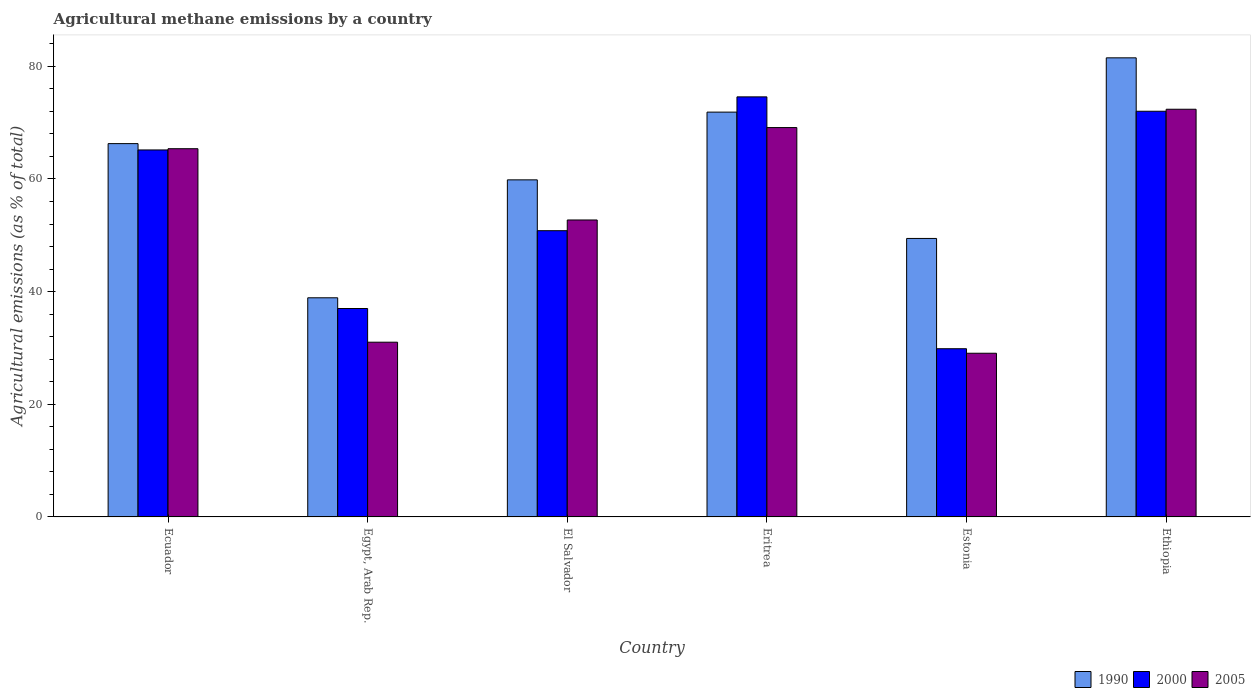How many groups of bars are there?
Provide a short and direct response. 6. How many bars are there on the 1st tick from the left?
Provide a short and direct response. 3. What is the label of the 4th group of bars from the left?
Provide a succinct answer. Eritrea. What is the amount of agricultural methane emitted in 2000 in Ethiopia?
Offer a very short reply. 72.02. Across all countries, what is the maximum amount of agricultural methane emitted in 1990?
Ensure brevity in your answer.  81.5. Across all countries, what is the minimum amount of agricultural methane emitted in 2005?
Keep it short and to the point. 29.06. In which country was the amount of agricultural methane emitted in 1990 maximum?
Keep it short and to the point. Ethiopia. In which country was the amount of agricultural methane emitted in 2005 minimum?
Ensure brevity in your answer.  Estonia. What is the total amount of agricultural methane emitted in 2005 in the graph?
Offer a very short reply. 319.67. What is the difference between the amount of agricultural methane emitted in 1990 in Ecuador and that in Ethiopia?
Your answer should be very brief. -15.23. What is the difference between the amount of agricultural methane emitted in 1990 in Estonia and the amount of agricultural methane emitted in 2005 in Egypt, Arab Rep.?
Provide a short and direct response. 18.42. What is the average amount of agricultural methane emitted in 2005 per country?
Your answer should be very brief. 53.28. What is the difference between the amount of agricultural methane emitted of/in 2005 and amount of agricultural methane emitted of/in 2000 in Eritrea?
Offer a terse response. -5.45. In how many countries, is the amount of agricultural methane emitted in 2000 greater than 40 %?
Provide a short and direct response. 4. What is the ratio of the amount of agricultural methane emitted in 2000 in Eritrea to that in Estonia?
Give a very brief answer. 2.5. Is the difference between the amount of agricultural methane emitted in 2005 in El Salvador and Ethiopia greater than the difference between the amount of agricultural methane emitted in 2000 in El Salvador and Ethiopia?
Your response must be concise. Yes. What is the difference between the highest and the second highest amount of agricultural methane emitted in 2000?
Give a very brief answer. 6.87. What is the difference between the highest and the lowest amount of agricultural methane emitted in 2005?
Offer a very short reply. 43.32. Is the sum of the amount of agricultural methane emitted in 1990 in Ecuador and Eritrea greater than the maximum amount of agricultural methane emitted in 2000 across all countries?
Offer a very short reply. Yes. What does the 1st bar from the left in Estonia represents?
Keep it short and to the point. 1990. What does the 2nd bar from the right in Ecuador represents?
Ensure brevity in your answer.  2000. Is it the case that in every country, the sum of the amount of agricultural methane emitted in 2000 and amount of agricultural methane emitted in 2005 is greater than the amount of agricultural methane emitted in 1990?
Your answer should be very brief. Yes. Are all the bars in the graph horizontal?
Ensure brevity in your answer.  No. How many countries are there in the graph?
Your response must be concise. 6. Does the graph contain any zero values?
Offer a very short reply. No. How are the legend labels stacked?
Your answer should be compact. Horizontal. What is the title of the graph?
Make the answer very short. Agricultural methane emissions by a country. What is the label or title of the Y-axis?
Keep it short and to the point. Agricultural emissions (as % of total). What is the Agricultural emissions (as % of total) in 1990 in Ecuador?
Offer a very short reply. 66.27. What is the Agricultural emissions (as % of total) of 2000 in Ecuador?
Offer a very short reply. 65.15. What is the Agricultural emissions (as % of total) of 2005 in Ecuador?
Keep it short and to the point. 65.37. What is the Agricultural emissions (as % of total) of 1990 in Egypt, Arab Rep.?
Provide a succinct answer. 38.9. What is the Agricultural emissions (as % of total) of 2000 in Egypt, Arab Rep.?
Your response must be concise. 37. What is the Agricultural emissions (as % of total) of 2005 in Egypt, Arab Rep.?
Make the answer very short. 31.02. What is the Agricultural emissions (as % of total) of 1990 in El Salvador?
Your answer should be very brief. 59.84. What is the Agricultural emissions (as % of total) of 2000 in El Salvador?
Make the answer very short. 50.82. What is the Agricultural emissions (as % of total) in 2005 in El Salvador?
Keep it short and to the point. 52.72. What is the Agricultural emissions (as % of total) of 1990 in Eritrea?
Offer a terse response. 71.87. What is the Agricultural emissions (as % of total) in 2000 in Eritrea?
Your answer should be compact. 74.57. What is the Agricultural emissions (as % of total) of 2005 in Eritrea?
Ensure brevity in your answer.  69.12. What is the Agricultural emissions (as % of total) in 1990 in Estonia?
Offer a terse response. 49.44. What is the Agricultural emissions (as % of total) of 2000 in Estonia?
Your response must be concise. 29.86. What is the Agricultural emissions (as % of total) in 2005 in Estonia?
Your response must be concise. 29.06. What is the Agricultural emissions (as % of total) in 1990 in Ethiopia?
Your answer should be very brief. 81.5. What is the Agricultural emissions (as % of total) in 2000 in Ethiopia?
Provide a succinct answer. 72.02. What is the Agricultural emissions (as % of total) of 2005 in Ethiopia?
Ensure brevity in your answer.  72.38. Across all countries, what is the maximum Agricultural emissions (as % of total) of 1990?
Ensure brevity in your answer.  81.5. Across all countries, what is the maximum Agricultural emissions (as % of total) of 2000?
Make the answer very short. 74.57. Across all countries, what is the maximum Agricultural emissions (as % of total) of 2005?
Make the answer very short. 72.38. Across all countries, what is the minimum Agricultural emissions (as % of total) in 1990?
Provide a succinct answer. 38.9. Across all countries, what is the minimum Agricultural emissions (as % of total) of 2000?
Provide a short and direct response. 29.86. Across all countries, what is the minimum Agricultural emissions (as % of total) of 2005?
Give a very brief answer. 29.06. What is the total Agricultural emissions (as % of total) in 1990 in the graph?
Your answer should be compact. 367.83. What is the total Agricultural emissions (as % of total) in 2000 in the graph?
Offer a very short reply. 329.43. What is the total Agricultural emissions (as % of total) of 2005 in the graph?
Make the answer very short. 319.67. What is the difference between the Agricultural emissions (as % of total) of 1990 in Ecuador and that in Egypt, Arab Rep.?
Give a very brief answer. 27.37. What is the difference between the Agricultural emissions (as % of total) in 2000 in Ecuador and that in Egypt, Arab Rep.?
Offer a terse response. 28.15. What is the difference between the Agricultural emissions (as % of total) in 2005 in Ecuador and that in Egypt, Arab Rep.?
Make the answer very short. 34.35. What is the difference between the Agricultural emissions (as % of total) in 1990 in Ecuador and that in El Salvador?
Give a very brief answer. 6.43. What is the difference between the Agricultural emissions (as % of total) of 2000 in Ecuador and that in El Salvador?
Provide a short and direct response. 14.33. What is the difference between the Agricultural emissions (as % of total) in 2005 in Ecuador and that in El Salvador?
Make the answer very short. 12.65. What is the difference between the Agricultural emissions (as % of total) in 1990 in Ecuador and that in Eritrea?
Give a very brief answer. -5.59. What is the difference between the Agricultural emissions (as % of total) in 2000 in Ecuador and that in Eritrea?
Provide a short and direct response. -9.42. What is the difference between the Agricultural emissions (as % of total) in 2005 in Ecuador and that in Eritrea?
Ensure brevity in your answer.  -3.75. What is the difference between the Agricultural emissions (as % of total) of 1990 in Ecuador and that in Estonia?
Your response must be concise. 16.84. What is the difference between the Agricultural emissions (as % of total) in 2000 in Ecuador and that in Estonia?
Your answer should be very brief. 35.29. What is the difference between the Agricultural emissions (as % of total) of 2005 in Ecuador and that in Estonia?
Provide a succinct answer. 36.31. What is the difference between the Agricultural emissions (as % of total) in 1990 in Ecuador and that in Ethiopia?
Provide a succinct answer. -15.23. What is the difference between the Agricultural emissions (as % of total) of 2000 in Ecuador and that in Ethiopia?
Offer a terse response. -6.87. What is the difference between the Agricultural emissions (as % of total) in 2005 in Ecuador and that in Ethiopia?
Your answer should be compact. -7. What is the difference between the Agricultural emissions (as % of total) in 1990 in Egypt, Arab Rep. and that in El Salvador?
Give a very brief answer. -20.94. What is the difference between the Agricultural emissions (as % of total) in 2000 in Egypt, Arab Rep. and that in El Salvador?
Keep it short and to the point. -13.82. What is the difference between the Agricultural emissions (as % of total) in 2005 in Egypt, Arab Rep. and that in El Salvador?
Offer a very short reply. -21.7. What is the difference between the Agricultural emissions (as % of total) in 1990 in Egypt, Arab Rep. and that in Eritrea?
Give a very brief answer. -32.96. What is the difference between the Agricultural emissions (as % of total) in 2000 in Egypt, Arab Rep. and that in Eritrea?
Ensure brevity in your answer.  -37.57. What is the difference between the Agricultural emissions (as % of total) of 2005 in Egypt, Arab Rep. and that in Eritrea?
Provide a succinct answer. -38.1. What is the difference between the Agricultural emissions (as % of total) in 1990 in Egypt, Arab Rep. and that in Estonia?
Keep it short and to the point. -10.53. What is the difference between the Agricultural emissions (as % of total) in 2000 in Egypt, Arab Rep. and that in Estonia?
Your response must be concise. 7.14. What is the difference between the Agricultural emissions (as % of total) in 2005 in Egypt, Arab Rep. and that in Estonia?
Offer a terse response. 1.96. What is the difference between the Agricultural emissions (as % of total) of 1990 in Egypt, Arab Rep. and that in Ethiopia?
Provide a succinct answer. -42.6. What is the difference between the Agricultural emissions (as % of total) in 2000 in Egypt, Arab Rep. and that in Ethiopia?
Your answer should be compact. -35.02. What is the difference between the Agricultural emissions (as % of total) in 2005 in Egypt, Arab Rep. and that in Ethiopia?
Offer a very short reply. -41.36. What is the difference between the Agricultural emissions (as % of total) of 1990 in El Salvador and that in Eritrea?
Your response must be concise. -12.03. What is the difference between the Agricultural emissions (as % of total) of 2000 in El Salvador and that in Eritrea?
Give a very brief answer. -23.76. What is the difference between the Agricultural emissions (as % of total) of 2005 in El Salvador and that in Eritrea?
Provide a succinct answer. -16.4. What is the difference between the Agricultural emissions (as % of total) of 1990 in El Salvador and that in Estonia?
Your answer should be very brief. 10.4. What is the difference between the Agricultural emissions (as % of total) of 2000 in El Salvador and that in Estonia?
Your answer should be compact. 20.96. What is the difference between the Agricultural emissions (as % of total) in 2005 in El Salvador and that in Estonia?
Your response must be concise. 23.66. What is the difference between the Agricultural emissions (as % of total) of 1990 in El Salvador and that in Ethiopia?
Keep it short and to the point. -21.66. What is the difference between the Agricultural emissions (as % of total) in 2000 in El Salvador and that in Ethiopia?
Offer a very short reply. -21.21. What is the difference between the Agricultural emissions (as % of total) of 2005 in El Salvador and that in Ethiopia?
Offer a terse response. -19.66. What is the difference between the Agricultural emissions (as % of total) in 1990 in Eritrea and that in Estonia?
Make the answer very short. 22.43. What is the difference between the Agricultural emissions (as % of total) of 2000 in Eritrea and that in Estonia?
Your answer should be very brief. 44.71. What is the difference between the Agricultural emissions (as % of total) of 2005 in Eritrea and that in Estonia?
Provide a succinct answer. 40.06. What is the difference between the Agricultural emissions (as % of total) in 1990 in Eritrea and that in Ethiopia?
Your response must be concise. -9.64. What is the difference between the Agricultural emissions (as % of total) of 2000 in Eritrea and that in Ethiopia?
Offer a very short reply. 2.55. What is the difference between the Agricultural emissions (as % of total) of 2005 in Eritrea and that in Ethiopia?
Offer a very short reply. -3.25. What is the difference between the Agricultural emissions (as % of total) in 1990 in Estonia and that in Ethiopia?
Ensure brevity in your answer.  -32.07. What is the difference between the Agricultural emissions (as % of total) in 2000 in Estonia and that in Ethiopia?
Offer a terse response. -42.16. What is the difference between the Agricultural emissions (as % of total) of 2005 in Estonia and that in Ethiopia?
Offer a terse response. -43.32. What is the difference between the Agricultural emissions (as % of total) of 1990 in Ecuador and the Agricultural emissions (as % of total) of 2000 in Egypt, Arab Rep.?
Give a very brief answer. 29.27. What is the difference between the Agricultural emissions (as % of total) in 1990 in Ecuador and the Agricultural emissions (as % of total) in 2005 in Egypt, Arab Rep.?
Provide a succinct answer. 35.25. What is the difference between the Agricultural emissions (as % of total) in 2000 in Ecuador and the Agricultural emissions (as % of total) in 2005 in Egypt, Arab Rep.?
Make the answer very short. 34.13. What is the difference between the Agricultural emissions (as % of total) of 1990 in Ecuador and the Agricultural emissions (as % of total) of 2000 in El Salvador?
Offer a terse response. 15.46. What is the difference between the Agricultural emissions (as % of total) in 1990 in Ecuador and the Agricultural emissions (as % of total) in 2005 in El Salvador?
Keep it short and to the point. 13.56. What is the difference between the Agricultural emissions (as % of total) in 2000 in Ecuador and the Agricultural emissions (as % of total) in 2005 in El Salvador?
Provide a short and direct response. 12.43. What is the difference between the Agricultural emissions (as % of total) of 1990 in Ecuador and the Agricultural emissions (as % of total) of 2000 in Eritrea?
Your answer should be very brief. -8.3. What is the difference between the Agricultural emissions (as % of total) of 1990 in Ecuador and the Agricultural emissions (as % of total) of 2005 in Eritrea?
Your answer should be compact. -2.85. What is the difference between the Agricultural emissions (as % of total) in 2000 in Ecuador and the Agricultural emissions (as % of total) in 2005 in Eritrea?
Provide a short and direct response. -3.97. What is the difference between the Agricultural emissions (as % of total) in 1990 in Ecuador and the Agricultural emissions (as % of total) in 2000 in Estonia?
Your answer should be very brief. 36.41. What is the difference between the Agricultural emissions (as % of total) in 1990 in Ecuador and the Agricultural emissions (as % of total) in 2005 in Estonia?
Your response must be concise. 37.21. What is the difference between the Agricultural emissions (as % of total) in 2000 in Ecuador and the Agricultural emissions (as % of total) in 2005 in Estonia?
Offer a terse response. 36.09. What is the difference between the Agricultural emissions (as % of total) of 1990 in Ecuador and the Agricultural emissions (as % of total) of 2000 in Ethiopia?
Provide a short and direct response. -5.75. What is the difference between the Agricultural emissions (as % of total) in 1990 in Ecuador and the Agricultural emissions (as % of total) in 2005 in Ethiopia?
Your response must be concise. -6.1. What is the difference between the Agricultural emissions (as % of total) in 2000 in Ecuador and the Agricultural emissions (as % of total) in 2005 in Ethiopia?
Your response must be concise. -7.22. What is the difference between the Agricultural emissions (as % of total) of 1990 in Egypt, Arab Rep. and the Agricultural emissions (as % of total) of 2000 in El Salvador?
Your answer should be compact. -11.91. What is the difference between the Agricultural emissions (as % of total) of 1990 in Egypt, Arab Rep. and the Agricultural emissions (as % of total) of 2005 in El Salvador?
Give a very brief answer. -13.81. What is the difference between the Agricultural emissions (as % of total) in 2000 in Egypt, Arab Rep. and the Agricultural emissions (as % of total) in 2005 in El Salvador?
Your answer should be very brief. -15.72. What is the difference between the Agricultural emissions (as % of total) in 1990 in Egypt, Arab Rep. and the Agricultural emissions (as % of total) in 2000 in Eritrea?
Provide a succinct answer. -35.67. What is the difference between the Agricultural emissions (as % of total) in 1990 in Egypt, Arab Rep. and the Agricultural emissions (as % of total) in 2005 in Eritrea?
Provide a succinct answer. -30.22. What is the difference between the Agricultural emissions (as % of total) of 2000 in Egypt, Arab Rep. and the Agricultural emissions (as % of total) of 2005 in Eritrea?
Provide a succinct answer. -32.12. What is the difference between the Agricultural emissions (as % of total) in 1990 in Egypt, Arab Rep. and the Agricultural emissions (as % of total) in 2000 in Estonia?
Offer a terse response. 9.04. What is the difference between the Agricultural emissions (as % of total) in 1990 in Egypt, Arab Rep. and the Agricultural emissions (as % of total) in 2005 in Estonia?
Your answer should be compact. 9.84. What is the difference between the Agricultural emissions (as % of total) of 2000 in Egypt, Arab Rep. and the Agricultural emissions (as % of total) of 2005 in Estonia?
Keep it short and to the point. 7.94. What is the difference between the Agricultural emissions (as % of total) of 1990 in Egypt, Arab Rep. and the Agricultural emissions (as % of total) of 2000 in Ethiopia?
Keep it short and to the point. -33.12. What is the difference between the Agricultural emissions (as % of total) in 1990 in Egypt, Arab Rep. and the Agricultural emissions (as % of total) in 2005 in Ethiopia?
Your answer should be compact. -33.47. What is the difference between the Agricultural emissions (as % of total) in 2000 in Egypt, Arab Rep. and the Agricultural emissions (as % of total) in 2005 in Ethiopia?
Offer a very short reply. -35.37. What is the difference between the Agricultural emissions (as % of total) of 1990 in El Salvador and the Agricultural emissions (as % of total) of 2000 in Eritrea?
Offer a very short reply. -14.73. What is the difference between the Agricultural emissions (as % of total) in 1990 in El Salvador and the Agricultural emissions (as % of total) in 2005 in Eritrea?
Provide a short and direct response. -9.28. What is the difference between the Agricultural emissions (as % of total) of 2000 in El Salvador and the Agricultural emissions (as % of total) of 2005 in Eritrea?
Your response must be concise. -18.31. What is the difference between the Agricultural emissions (as % of total) in 1990 in El Salvador and the Agricultural emissions (as % of total) in 2000 in Estonia?
Give a very brief answer. 29.98. What is the difference between the Agricultural emissions (as % of total) of 1990 in El Salvador and the Agricultural emissions (as % of total) of 2005 in Estonia?
Offer a very short reply. 30.78. What is the difference between the Agricultural emissions (as % of total) of 2000 in El Salvador and the Agricultural emissions (as % of total) of 2005 in Estonia?
Your response must be concise. 21.76. What is the difference between the Agricultural emissions (as % of total) in 1990 in El Salvador and the Agricultural emissions (as % of total) in 2000 in Ethiopia?
Ensure brevity in your answer.  -12.18. What is the difference between the Agricultural emissions (as % of total) of 1990 in El Salvador and the Agricultural emissions (as % of total) of 2005 in Ethiopia?
Give a very brief answer. -12.53. What is the difference between the Agricultural emissions (as % of total) in 2000 in El Salvador and the Agricultural emissions (as % of total) in 2005 in Ethiopia?
Ensure brevity in your answer.  -21.56. What is the difference between the Agricultural emissions (as % of total) of 1990 in Eritrea and the Agricultural emissions (as % of total) of 2000 in Estonia?
Your answer should be compact. 42.01. What is the difference between the Agricultural emissions (as % of total) of 1990 in Eritrea and the Agricultural emissions (as % of total) of 2005 in Estonia?
Give a very brief answer. 42.81. What is the difference between the Agricultural emissions (as % of total) of 2000 in Eritrea and the Agricultural emissions (as % of total) of 2005 in Estonia?
Your response must be concise. 45.51. What is the difference between the Agricultural emissions (as % of total) in 1990 in Eritrea and the Agricultural emissions (as % of total) in 2000 in Ethiopia?
Your answer should be very brief. -0.16. What is the difference between the Agricultural emissions (as % of total) in 1990 in Eritrea and the Agricultural emissions (as % of total) in 2005 in Ethiopia?
Your response must be concise. -0.51. What is the difference between the Agricultural emissions (as % of total) in 2000 in Eritrea and the Agricultural emissions (as % of total) in 2005 in Ethiopia?
Your answer should be compact. 2.2. What is the difference between the Agricultural emissions (as % of total) of 1990 in Estonia and the Agricultural emissions (as % of total) of 2000 in Ethiopia?
Offer a terse response. -22.59. What is the difference between the Agricultural emissions (as % of total) of 1990 in Estonia and the Agricultural emissions (as % of total) of 2005 in Ethiopia?
Your response must be concise. -22.94. What is the difference between the Agricultural emissions (as % of total) in 2000 in Estonia and the Agricultural emissions (as % of total) in 2005 in Ethiopia?
Offer a terse response. -42.52. What is the average Agricultural emissions (as % of total) of 1990 per country?
Offer a terse response. 61.31. What is the average Agricultural emissions (as % of total) in 2000 per country?
Your answer should be very brief. 54.9. What is the average Agricultural emissions (as % of total) in 2005 per country?
Make the answer very short. 53.28. What is the difference between the Agricultural emissions (as % of total) of 1990 and Agricultural emissions (as % of total) of 2000 in Ecuador?
Provide a short and direct response. 1.12. What is the difference between the Agricultural emissions (as % of total) of 1990 and Agricultural emissions (as % of total) of 2005 in Ecuador?
Ensure brevity in your answer.  0.9. What is the difference between the Agricultural emissions (as % of total) of 2000 and Agricultural emissions (as % of total) of 2005 in Ecuador?
Give a very brief answer. -0.22. What is the difference between the Agricultural emissions (as % of total) of 1990 and Agricultural emissions (as % of total) of 2000 in Egypt, Arab Rep.?
Offer a very short reply. 1.9. What is the difference between the Agricultural emissions (as % of total) of 1990 and Agricultural emissions (as % of total) of 2005 in Egypt, Arab Rep.?
Provide a succinct answer. 7.88. What is the difference between the Agricultural emissions (as % of total) of 2000 and Agricultural emissions (as % of total) of 2005 in Egypt, Arab Rep.?
Your answer should be compact. 5.98. What is the difference between the Agricultural emissions (as % of total) in 1990 and Agricultural emissions (as % of total) in 2000 in El Salvador?
Provide a succinct answer. 9.02. What is the difference between the Agricultural emissions (as % of total) of 1990 and Agricultural emissions (as % of total) of 2005 in El Salvador?
Ensure brevity in your answer.  7.12. What is the difference between the Agricultural emissions (as % of total) of 2000 and Agricultural emissions (as % of total) of 2005 in El Salvador?
Ensure brevity in your answer.  -1.9. What is the difference between the Agricultural emissions (as % of total) of 1990 and Agricultural emissions (as % of total) of 2000 in Eritrea?
Offer a terse response. -2.71. What is the difference between the Agricultural emissions (as % of total) in 1990 and Agricultural emissions (as % of total) in 2005 in Eritrea?
Your answer should be compact. 2.75. What is the difference between the Agricultural emissions (as % of total) of 2000 and Agricultural emissions (as % of total) of 2005 in Eritrea?
Provide a short and direct response. 5.45. What is the difference between the Agricultural emissions (as % of total) in 1990 and Agricultural emissions (as % of total) in 2000 in Estonia?
Your response must be concise. 19.58. What is the difference between the Agricultural emissions (as % of total) in 1990 and Agricultural emissions (as % of total) in 2005 in Estonia?
Offer a terse response. 20.38. What is the difference between the Agricultural emissions (as % of total) in 2000 and Agricultural emissions (as % of total) in 2005 in Estonia?
Provide a short and direct response. 0.8. What is the difference between the Agricultural emissions (as % of total) of 1990 and Agricultural emissions (as % of total) of 2000 in Ethiopia?
Give a very brief answer. 9.48. What is the difference between the Agricultural emissions (as % of total) of 1990 and Agricultural emissions (as % of total) of 2005 in Ethiopia?
Your response must be concise. 9.13. What is the difference between the Agricultural emissions (as % of total) of 2000 and Agricultural emissions (as % of total) of 2005 in Ethiopia?
Provide a succinct answer. -0.35. What is the ratio of the Agricultural emissions (as % of total) in 1990 in Ecuador to that in Egypt, Arab Rep.?
Make the answer very short. 1.7. What is the ratio of the Agricultural emissions (as % of total) in 2000 in Ecuador to that in Egypt, Arab Rep.?
Your response must be concise. 1.76. What is the ratio of the Agricultural emissions (as % of total) in 2005 in Ecuador to that in Egypt, Arab Rep.?
Offer a terse response. 2.11. What is the ratio of the Agricultural emissions (as % of total) of 1990 in Ecuador to that in El Salvador?
Keep it short and to the point. 1.11. What is the ratio of the Agricultural emissions (as % of total) of 2000 in Ecuador to that in El Salvador?
Your response must be concise. 1.28. What is the ratio of the Agricultural emissions (as % of total) in 2005 in Ecuador to that in El Salvador?
Your answer should be very brief. 1.24. What is the ratio of the Agricultural emissions (as % of total) of 1990 in Ecuador to that in Eritrea?
Offer a very short reply. 0.92. What is the ratio of the Agricultural emissions (as % of total) in 2000 in Ecuador to that in Eritrea?
Your answer should be compact. 0.87. What is the ratio of the Agricultural emissions (as % of total) of 2005 in Ecuador to that in Eritrea?
Your answer should be very brief. 0.95. What is the ratio of the Agricultural emissions (as % of total) of 1990 in Ecuador to that in Estonia?
Make the answer very short. 1.34. What is the ratio of the Agricultural emissions (as % of total) in 2000 in Ecuador to that in Estonia?
Provide a short and direct response. 2.18. What is the ratio of the Agricultural emissions (as % of total) in 2005 in Ecuador to that in Estonia?
Ensure brevity in your answer.  2.25. What is the ratio of the Agricultural emissions (as % of total) in 1990 in Ecuador to that in Ethiopia?
Provide a succinct answer. 0.81. What is the ratio of the Agricultural emissions (as % of total) in 2000 in Ecuador to that in Ethiopia?
Your answer should be very brief. 0.9. What is the ratio of the Agricultural emissions (as % of total) in 2005 in Ecuador to that in Ethiopia?
Your answer should be very brief. 0.9. What is the ratio of the Agricultural emissions (as % of total) in 1990 in Egypt, Arab Rep. to that in El Salvador?
Your answer should be very brief. 0.65. What is the ratio of the Agricultural emissions (as % of total) of 2000 in Egypt, Arab Rep. to that in El Salvador?
Provide a short and direct response. 0.73. What is the ratio of the Agricultural emissions (as % of total) of 2005 in Egypt, Arab Rep. to that in El Salvador?
Your response must be concise. 0.59. What is the ratio of the Agricultural emissions (as % of total) in 1990 in Egypt, Arab Rep. to that in Eritrea?
Give a very brief answer. 0.54. What is the ratio of the Agricultural emissions (as % of total) in 2000 in Egypt, Arab Rep. to that in Eritrea?
Provide a succinct answer. 0.5. What is the ratio of the Agricultural emissions (as % of total) in 2005 in Egypt, Arab Rep. to that in Eritrea?
Make the answer very short. 0.45. What is the ratio of the Agricultural emissions (as % of total) of 1990 in Egypt, Arab Rep. to that in Estonia?
Your answer should be compact. 0.79. What is the ratio of the Agricultural emissions (as % of total) of 2000 in Egypt, Arab Rep. to that in Estonia?
Keep it short and to the point. 1.24. What is the ratio of the Agricultural emissions (as % of total) of 2005 in Egypt, Arab Rep. to that in Estonia?
Ensure brevity in your answer.  1.07. What is the ratio of the Agricultural emissions (as % of total) in 1990 in Egypt, Arab Rep. to that in Ethiopia?
Your answer should be very brief. 0.48. What is the ratio of the Agricultural emissions (as % of total) of 2000 in Egypt, Arab Rep. to that in Ethiopia?
Provide a short and direct response. 0.51. What is the ratio of the Agricultural emissions (as % of total) of 2005 in Egypt, Arab Rep. to that in Ethiopia?
Provide a short and direct response. 0.43. What is the ratio of the Agricultural emissions (as % of total) in 1990 in El Salvador to that in Eritrea?
Provide a succinct answer. 0.83. What is the ratio of the Agricultural emissions (as % of total) in 2000 in El Salvador to that in Eritrea?
Offer a terse response. 0.68. What is the ratio of the Agricultural emissions (as % of total) of 2005 in El Salvador to that in Eritrea?
Provide a short and direct response. 0.76. What is the ratio of the Agricultural emissions (as % of total) in 1990 in El Salvador to that in Estonia?
Your answer should be very brief. 1.21. What is the ratio of the Agricultural emissions (as % of total) in 2000 in El Salvador to that in Estonia?
Offer a terse response. 1.7. What is the ratio of the Agricultural emissions (as % of total) in 2005 in El Salvador to that in Estonia?
Provide a short and direct response. 1.81. What is the ratio of the Agricultural emissions (as % of total) in 1990 in El Salvador to that in Ethiopia?
Your answer should be very brief. 0.73. What is the ratio of the Agricultural emissions (as % of total) of 2000 in El Salvador to that in Ethiopia?
Offer a terse response. 0.71. What is the ratio of the Agricultural emissions (as % of total) in 2005 in El Salvador to that in Ethiopia?
Your answer should be very brief. 0.73. What is the ratio of the Agricultural emissions (as % of total) in 1990 in Eritrea to that in Estonia?
Your answer should be compact. 1.45. What is the ratio of the Agricultural emissions (as % of total) in 2000 in Eritrea to that in Estonia?
Your response must be concise. 2.5. What is the ratio of the Agricultural emissions (as % of total) in 2005 in Eritrea to that in Estonia?
Offer a very short reply. 2.38. What is the ratio of the Agricultural emissions (as % of total) of 1990 in Eritrea to that in Ethiopia?
Offer a very short reply. 0.88. What is the ratio of the Agricultural emissions (as % of total) in 2000 in Eritrea to that in Ethiopia?
Offer a terse response. 1.04. What is the ratio of the Agricultural emissions (as % of total) in 2005 in Eritrea to that in Ethiopia?
Offer a very short reply. 0.96. What is the ratio of the Agricultural emissions (as % of total) in 1990 in Estonia to that in Ethiopia?
Ensure brevity in your answer.  0.61. What is the ratio of the Agricultural emissions (as % of total) of 2000 in Estonia to that in Ethiopia?
Keep it short and to the point. 0.41. What is the ratio of the Agricultural emissions (as % of total) of 2005 in Estonia to that in Ethiopia?
Provide a succinct answer. 0.4. What is the difference between the highest and the second highest Agricultural emissions (as % of total) of 1990?
Provide a succinct answer. 9.64. What is the difference between the highest and the second highest Agricultural emissions (as % of total) of 2000?
Offer a very short reply. 2.55. What is the difference between the highest and the second highest Agricultural emissions (as % of total) in 2005?
Offer a terse response. 3.25. What is the difference between the highest and the lowest Agricultural emissions (as % of total) of 1990?
Offer a terse response. 42.6. What is the difference between the highest and the lowest Agricultural emissions (as % of total) of 2000?
Offer a terse response. 44.71. What is the difference between the highest and the lowest Agricultural emissions (as % of total) of 2005?
Provide a short and direct response. 43.32. 